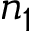Convert formula to latex. <formula><loc_0><loc_0><loc_500><loc_500>n _ { 1 }</formula> 